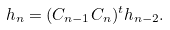<formula> <loc_0><loc_0><loc_500><loc_500>h _ { n } = ( C _ { n - 1 } C _ { n } ) ^ { t } h _ { n - 2 } .</formula> 